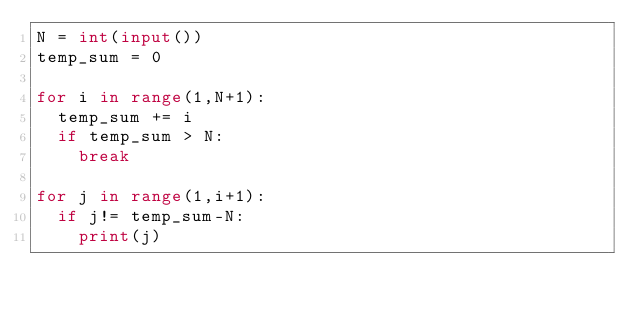Convert code to text. <code><loc_0><loc_0><loc_500><loc_500><_Python_>N = int(input())
temp_sum = 0

for i in range(1,N+1):
  temp_sum += i
  if temp_sum > N:
    break
    
for j in range(1,i+1):
  if j!= temp_sum-N:
    print(j)</code> 